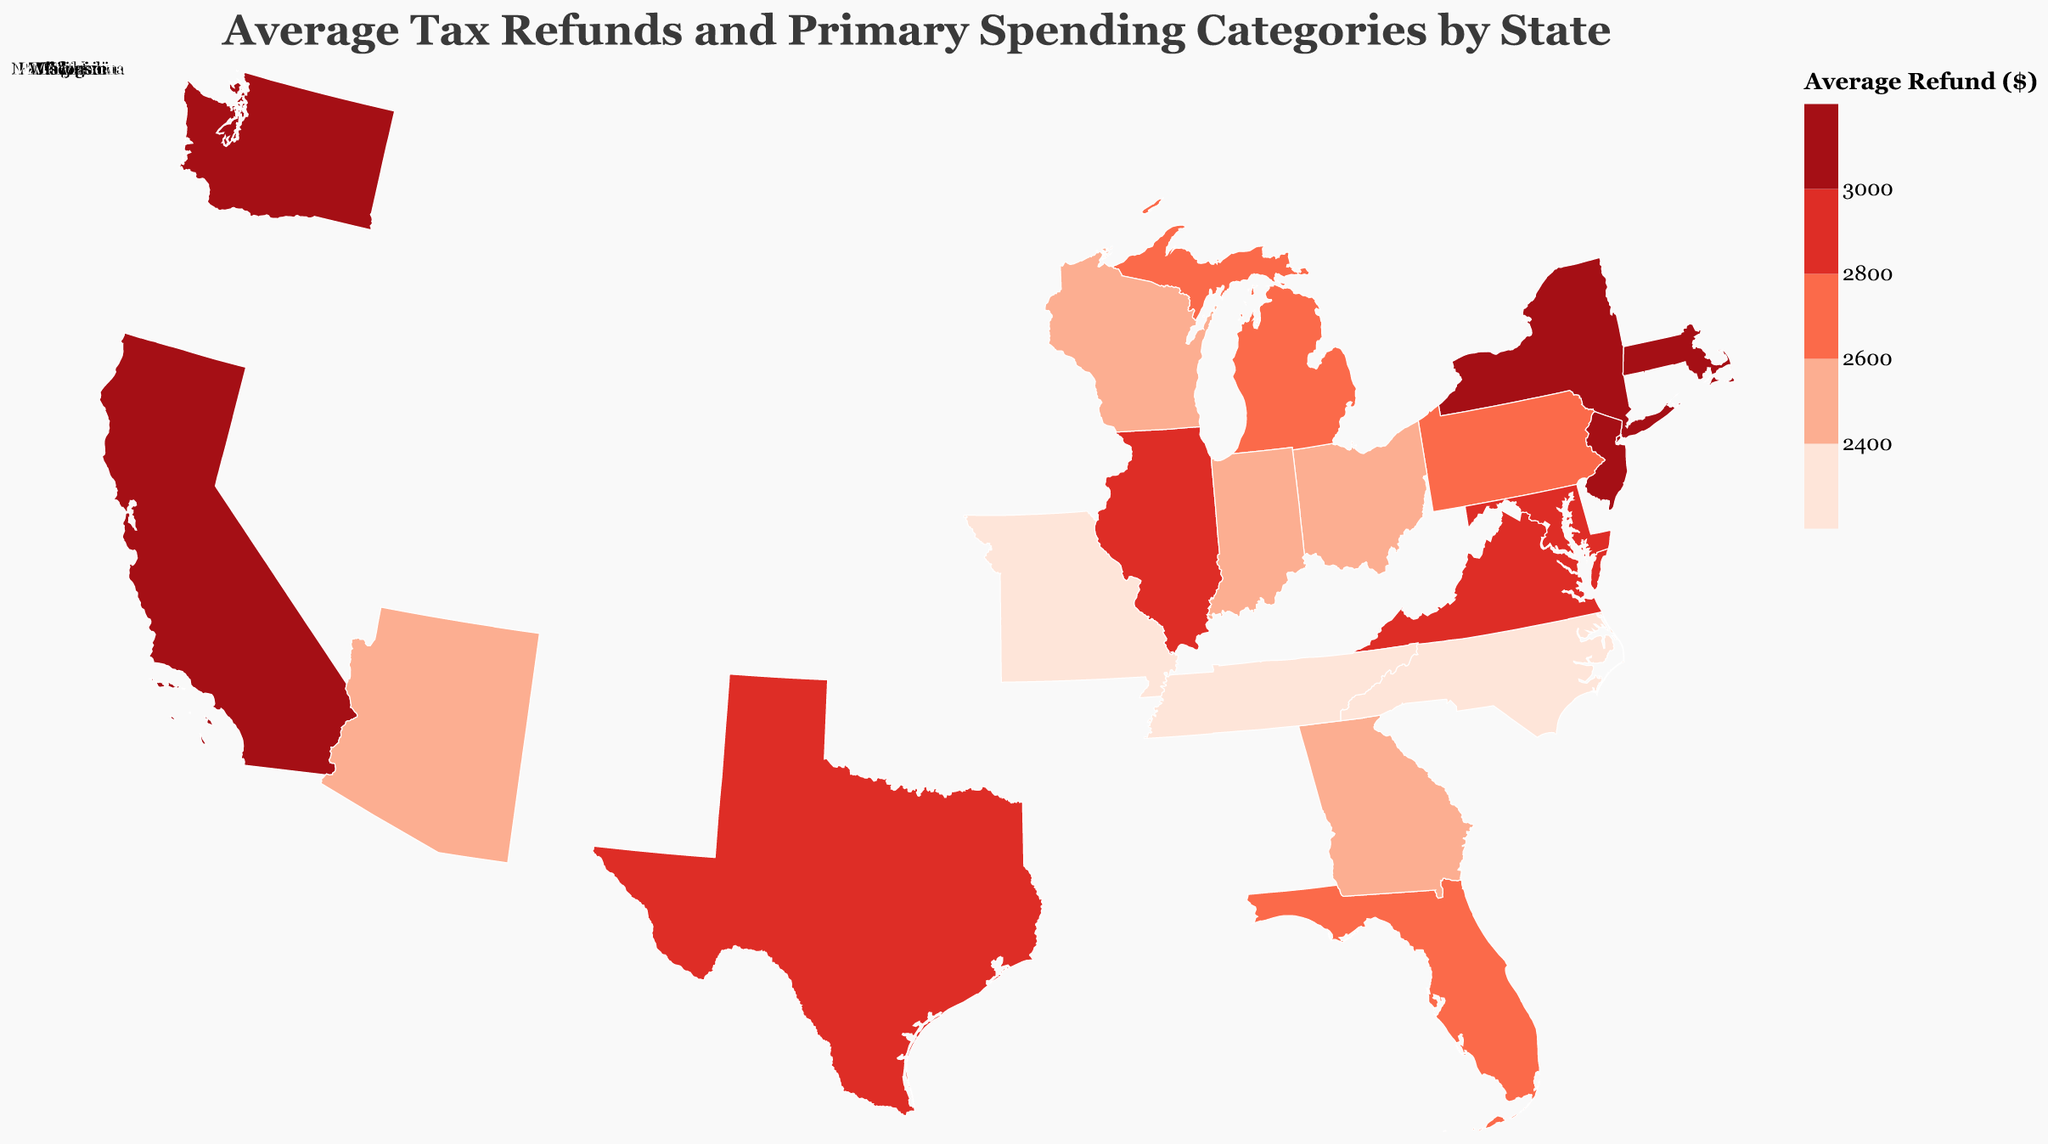What's the title of the figure? The title is usually placed at the top of the plot and describes what the plot is about. Here, it says "Average Tax Refunds and Primary Spending Categories by State" at the top of the figure.
Answer: Average Tax Refunds and Primary Spending Categories by State Which state has the highest average tax refund? From the color coding and the tooltip data, the state with the highest average refund can be identified by the darkest color which is "$3,200". Both California and Massachusetts have this value.
Answer: California and Massachusetts Which state has the lowest average tax refund? By examining the color coding and tooltip, we see the lightest color represents the lowest average refund, "$2,200". This value is present in Tennessee.
Answer: Tennessee What is the primary spending category for Texas? The tooltip information shows the primary spending category for each state. For Texas, it is "Debt Repayment".
Answer: Debt Repayment How much higher is California's average tax refund compared to Ohio's? California's average refund is $3,200, and Ohio's is $2,500. The difference is $3,200 - $2,500 = $700.
Answer: $700 Which states have average refunds above $3000? By examining the color gradient and tooltip data, California, New York, Washington, and Massachusetts have average refunds above $3000.
Answer: California, New York, Washington, Massachusetts How many states have average tax refunds less than $2500? By identifying the states with colors representing refunds less than $2500, we see Georgia (2400), North Carolina (2300), Tennessee (2200), Indiana (2400), and Missouri (2300). That's five states.
Answer: 5 states Compare the primary spending categories for Illinois and Pennsylvania. The tooltip provides the primary spending categories: Illinois is mainly spending on Education, while Pennsylvania prioritizes Retirement Contributions.
Answer: Education and Retirement Contributions What average refund value and primary spending category are associated with Maryland? By hovering over Maryland, the tooltip shows that the average refund is $2,900, and the primary spending category is "Home Down Payment".
Answer: $2,900 and Home Down Payment 